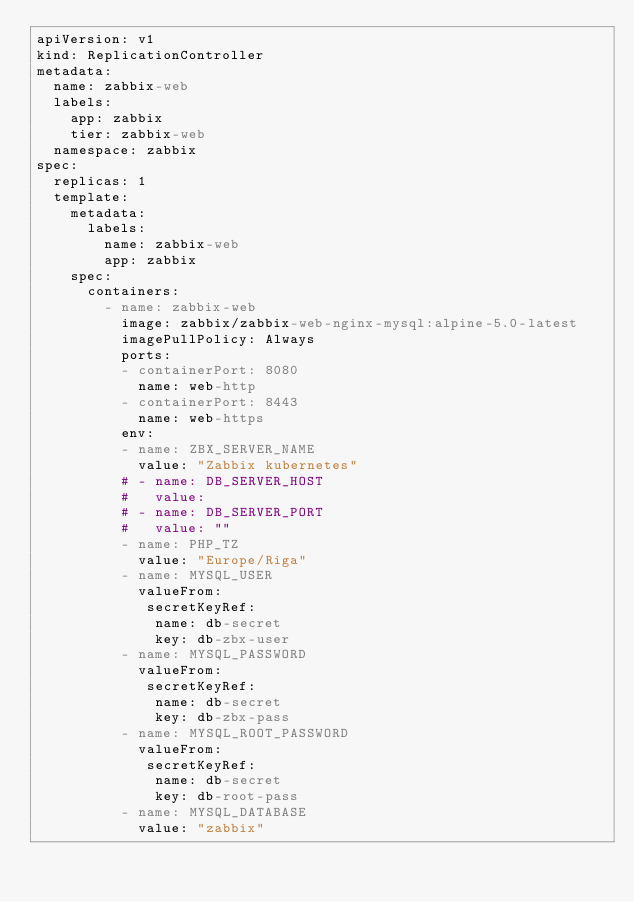<code> <loc_0><loc_0><loc_500><loc_500><_YAML_>apiVersion: v1
kind: ReplicationController
metadata:
  name: zabbix-web
  labels:
    app: zabbix
    tier: zabbix-web
  namespace: zabbix
spec:
  replicas: 1
  template:
    metadata:
      labels:
        name: zabbix-web
        app: zabbix
    spec:
      containers:
        - name: zabbix-web
          image: zabbix/zabbix-web-nginx-mysql:alpine-5.0-latest
          imagePullPolicy: Always
          ports:
          - containerPort: 8080
            name: web-http
          - containerPort: 8443
            name: web-https
          env:
          - name: ZBX_SERVER_NAME
            value: "Zabbix kubernetes"
          # - name: DB_SERVER_HOST
          #   value: 
          # - name: DB_SERVER_PORT
          #   value: ""
          - name: PHP_TZ
            value: "Europe/Riga"
          - name: MYSQL_USER
            valueFrom:
             secretKeyRef:
              name: db-secret
              key: db-zbx-user
          - name: MYSQL_PASSWORD
            valueFrom:
             secretKeyRef:
              name: db-secret
              key: db-zbx-pass
          - name: MYSQL_ROOT_PASSWORD
            valueFrom:
             secretKeyRef:
              name: db-secret
              key: db-root-pass
          - name: MYSQL_DATABASE
            value: "zabbix"</code> 